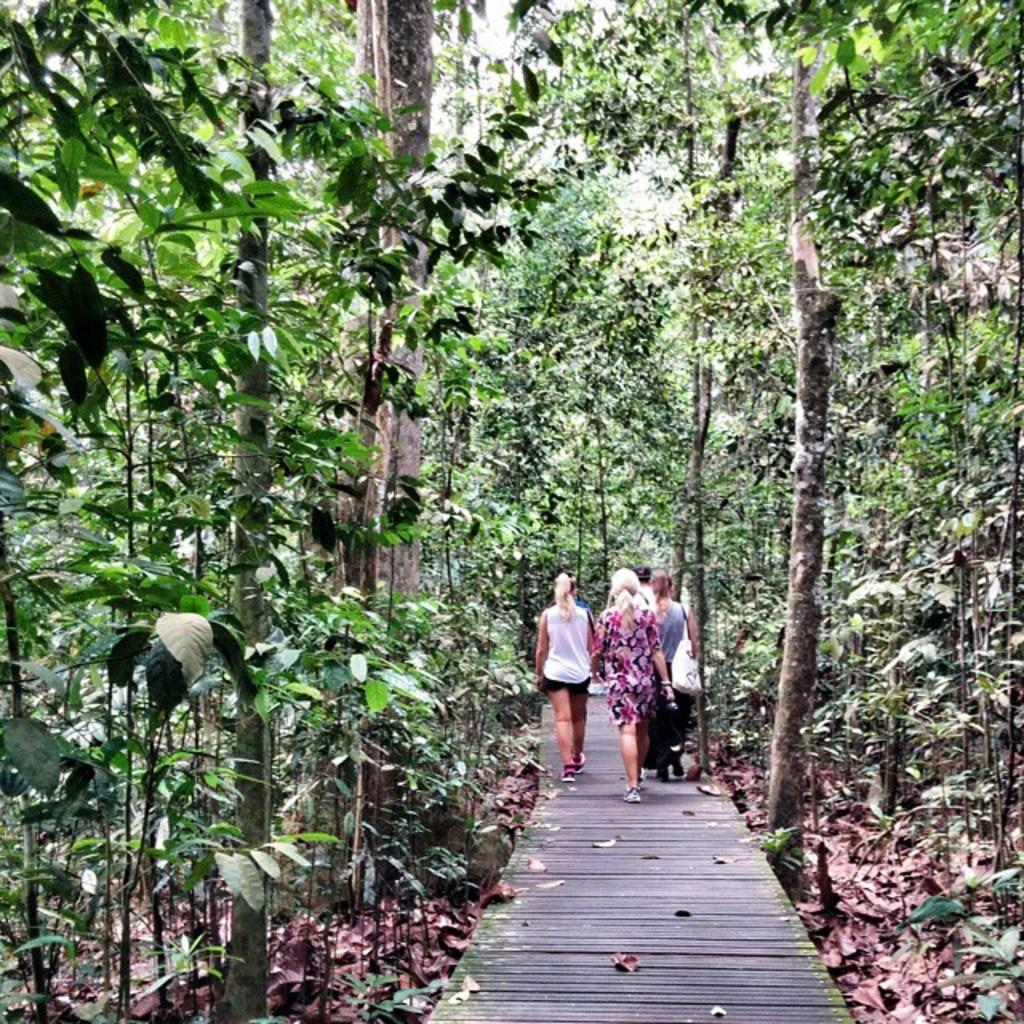What are the people in the image doing? The people in the image are walking. What type of surface are the people walking on? The people are walking on a wooden surface. What can be seen in the background of the image? There is a group of trees in the image. What type of vegetation is present in the image? Dried leaves are present in the image. What type of waste can be seen being removed from a vein during an operation in the image? There is no waste, vein, or operation present in the image. 